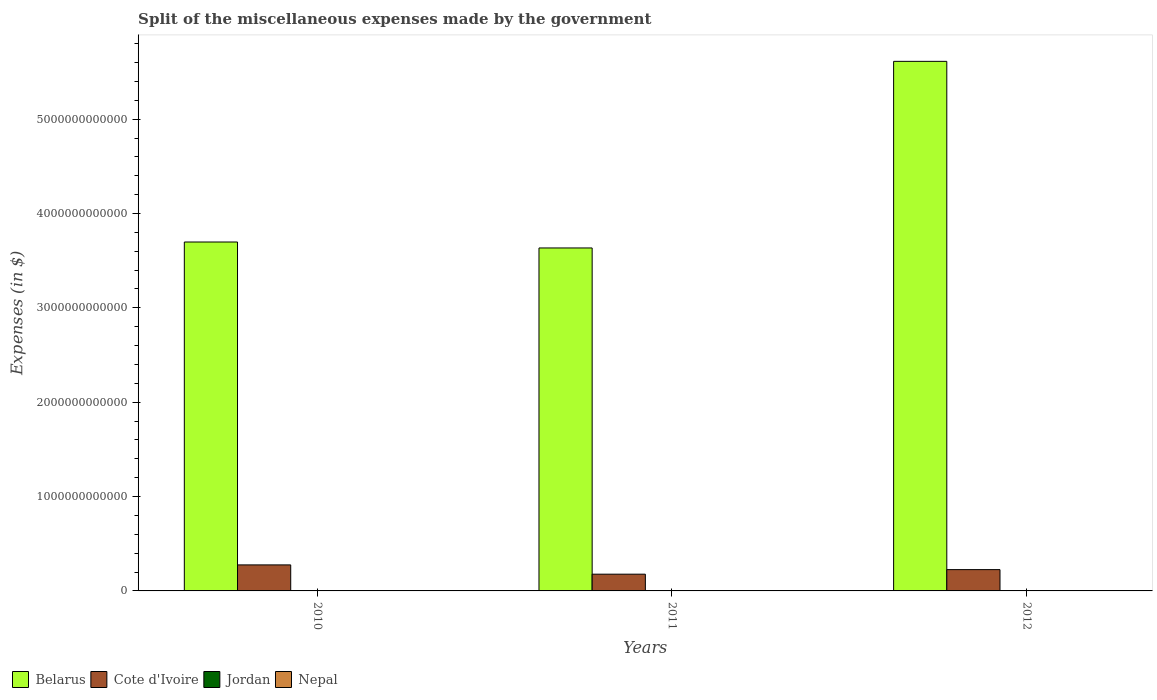How many different coloured bars are there?
Keep it short and to the point. 4. Are the number of bars per tick equal to the number of legend labels?
Offer a very short reply. Yes. What is the label of the 3rd group of bars from the left?
Offer a terse response. 2012. What is the miscellaneous expenses made by the government in Jordan in 2012?
Offer a very short reply. 7.96e+07. Across all years, what is the maximum miscellaneous expenses made by the government in Cote d'Ivoire?
Ensure brevity in your answer.  2.76e+11. Across all years, what is the minimum miscellaneous expenses made by the government in Belarus?
Give a very brief answer. 3.63e+12. In which year was the miscellaneous expenses made by the government in Cote d'Ivoire maximum?
Offer a very short reply. 2010. What is the total miscellaneous expenses made by the government in Cote d'Ivoire in the graph?
Give a very brief answer. 6.79e+11. What is the difference between the miscellaneous expenses made by the government in Cote d'Ivoire in 2010 and that in 2011?
Offer a terse response. 9.83e+1. What is the difference between the miscellaneous expenses made by the government in Nepal in 2011 and the miscellaneous expenses made by the government in Belarus in 2012?
Ensure brevity in your answer.  -5.61e+12. What is the average miscellaneous expenses made by the government in Cote d'Ivoire per year?
Provide a succinct answer. 2.26e+11. In the year 2010, what is the difference between the miscellaneous expenses made by the government in Nepal and miscellaneous expenses made by the government in Belarus?
Offer a very short reply. -3.70e+12. What is the ratio of the miscellaneous expenses made by the government in Belarus in 2010 to that in 2011?
Give a very brief answer. 1.02. Is the miscellaneous expenses made by the government in Jordan in 2010 less than that in 2012?
Your answer should be compact. No. What is the difference between the highest and the second highest miscellaneous expenses made by the government in Cote d'Ivoire?
Offer a terse response. 5.00e+1. What is the difference between the highest and the lowest miscellaneous expenses made by the government in Jordan?
Your response must be concise. 1.71e+07. Is the sum of the miscellaneous expenses made by the government in Belarus in 2011 and 2012 greater than the maximum miscellaneous expenses made by the government in Nepal across all years?
Offer a terse response. Yes. Is it the case that in every year, the sum of the miscellaneous expenses made by the government in Cote d'Ivoire and miscellaneous expenses made by the government in Jordan is greater than the sum of miscellaneous expenses made by the government in Belarus and miscellaneous expenses made by the government in Nepal?
Ensure brevity in your answer.  No. What does the 4th bar from the left in 2010 represents?
Keep it short and to the point. Nepal. What does the 2nd bar from the right in 2010 represents?
Your response must be concise. Jordan. Is it the case that in every year, the sum of the miscellaneous expenses made by the government in Jordan and miscellaneous expenses made by the government in Nepal is greater than the miscellaneous expenses made by the government in Cote d'Ivoire?
Provide a short and direct response. No. How many bars are there?
Give a very brief answer. 12. What is the difference between two consecutive major ticks on the Y-axis?
Your answer should be compact. 1.00e+12. Does the graph contain any zero values?
Keep it short and to the point. No. Where does the legend appear in the graph?
Your answer should be very brief. Bottom left. How many legend labels are there?
Your answer should be very brief. 4. How are the legend labels stacked?
Ensure brevity in your answer.  Horizontal. What is the title of the graph?
Your answer should be compact. Split of the miscellaneous expenses made by the government. Does "Faeroe Islands" appear as one of the legend labels in the graph?
Make the answer very short. No. What is the label or title of the Y-axis?
Provide a succinct answer. Expenses (in $). What is the Expenses (in $) of Belarus in 2010?
Ensure brevity in your answer.  3.70e+12. What is the Expenses (in $) of Cote d'Ivoire in 2010?
Your response must be concise. 2.76e+11. What is the Expenses (in $) of Jordan in 2010?
Offer a very short reply. 9.67e+07. What is the Expenses (in $) of Nepal in 2010?
Your response must be concise. 1.38e+09. What is the Expenses (in $) in Belarus in 2011?
Offer a very short reply. 3.63e+12. What is the Expenses (in $) of Cote d'Ivoire in 2011?
Offer a terse response. 1.77e+11. What is the Expenses (in $) in Jordan in 2011?
Ensure brevity in your answer.  8.67e+07. What is the Expenses (in $) of Nepal in 2011?
Your answer should be very brief. 1.86e+09. What is the Expenses (in $) of Belarus in 2012?
Make the answer very short. 5.61e+12. What is the Expenses (in $) in Cote d'Ivoire in 2012?
Your answer should be compact. 2.26e+11. What is the Expenses (in $) of Jordan in 2012?
Ensure brevity in your answer.  7.96e+07. What is the Expenses (in $) of Nepal in 2012?
Keep it short and to the point. 2.00e+09. Across all years, what is the maximum Expenses (in $) in Belarus?
Offer a very short reply. 5.61e+12. Across all years, what is the maximum Expenses (in $) in Cote d'Ivoire?
Your answer should be very brief. 2.76e+11. Across all years, what is the maximum Expenses (in $) of Jordan?
Your answer should be very brief. 9.67e+07. Across all years, what is the maximum Expenses (in $) of Nepal?
Give a very brief answer. 2.00e+09. Across all years, what is the minimum Expenses (in $) in Belarus?
Your answer should be compact. 3.63e+12. Across all years, what is the minimum Expenses (in $) in Cote d'Ivoire?
Make the answer very short. 1.77e+11. Across all years, what is the minimum Expenses (in $) in Jordan?
Give a very brief answer. 7.96e+07. Across all years, what is the minimum Expenses (in $) of Nepal?
Your response must be concise. 1.38e+09. What is the total Expenses (in $) in Belarus in the graph?
Provide a succinct answer. 1.29e+13. What is the total Expenses (in $) of Cote d'Ivoire in the graph?
Make the answer very short. 6.79e+11. What is the total Expenses (in $) in Jordan in the graph?
Your answer should be very brief. 2.63e+08. What is the total Expenses (in $) of Nepal in the graph?
Offer a very short reply. 5.24e+09. What is the difference between the Expenses (in $) in Belarus in 2010 and that in 2011?
Your answer should be very brief. 6.31e+1. What is the difference between the Expenses (in $) of Cote d'Ivoire in 2010 and that in 2011?
Keep it short and to the point. 9.83e+1. What is the difference between the Expenses (in $) in Jordan in 2010 and that in 2011?
Keep it short and to the point. 1.00e+07. What is the difference between the Expenses (in $) of Nepal in 2010 and that in 2011?
Offer a very short reply. -4.77e+08. What is the difference between the Expenses (in $) in Belarus in 2010 and that in 2012?
Your answer should be very brief. -1.91e+12. What is the difference between the Expenses (in $) in Cote d'Ivoire in 2010 and that in 2012?
Provide a short and direct response. 5.00e+1. What is the difference between the Expenses (in $) of Jordan in 2010 and that in 2012?
Your answer should be very brief. 1.71e+07. What is the difference between the Expenses (in $) of Nepal in 2010 and that in 2012?
Your answer should be very brief. -6.13e+08. What is the difference between the Expenses (in $) in Belarus in 2011 and that in 2012?
Provide a succinct answer. -1.98e+12. What is the difference between the Expenses (in $) in Cote d'Ivoire in 2011 and that in 2012?
Your response must be concise. -4.83e+1. What is the difference between the Expenses (in $) of Jordan in 2011 and that in 2012?
Ensure brevity in your answer.  7.10e+06. What is the difference between the Expenses (in $) in Nepal in 2011 and that in 2012?
Keep it short and to the point. -1.36e+08. What is the difference between the Expenses (in $) in Belarus in 2010 and the Expenses (in $) in Cote d'Ivoire in 2011?
Your response must be concise. 3.52e+12. What is the difference between the Expenses (in $) of Belarus in 2010 and the Expenses (in $) of Jordan in 2011?
Your answer should be very brief. 3.70e+12. What is the difference between the Expenses (in $) of Belarus in 2010 and the Expenses (in $) of Nepal in 2011?
Offer a terse response. 3.70e+12. What is the difference between the Expenses (in $) of Cote d'Ivoire in 2010 and the Expenses (in $) of Jordan in 2011?
Keep it short and to the point. 2.76e+11. What is the difference between the Expenses (in $) of Cote d'Ivoire in 2010 and the Expenses (in $) of Nepal in 2011?
Keep it short and to the point. 2.74e+11. What is the difference between the Expenses (in $) of Jordan in 2010 and the Expenses (in $) of Nepal in 2011?
Your answer should be compact. -1.76e+09. What is the difference between the Expenses (in $) in Belarus in 2010 and the Expenses (in $) in Cote d'Ivoire in 2012?
Offer a terse response. 3.47e+12. What is the difference between the Expenses (in $) in Belarus in 2010 and the Expenses (in $) in Jordan in 2012?
Offer a very short reply. 3.70e+12. What is the difference between the Expenses (in $) of Belarus in 2010 and the Expenses (in $) of Nepal in 2012?
Offer a very short reply. 3.70e+12. What is the difference between the Expenses (in $) of Cote d'Ivoire in 2010 and the Expenses (in $) of Jordan in 2012?
Ensure brevity in your answer.  2.76e+11. What is the difference between the Expenses (in $) in Cote d'Ivoire in 2010 and the Expenses (in $) in Nepal in 2012?
Provide a short and direct response. 2.74e+11. What is the difference between the Expenses (in $) of Jordan in 2010 and the Expenses (in $) of Nepal in 2012?
Make the answer very short. -1.90e+09. What is the difference between the Expenses (in $) of Belarus in 2011 and the Expenses (in $) of Cote d'Ivoire in 2012?
Your response must be concise. 3.41e+12. What is the difference between the Expenses (in $) in Belarus in 2011 and the Expenses (in $) in Jordan in 2012?
Offer a terse response. 3.63e+12. What is the difference between the Expenses (in $) in Belarus in 2011 and the Expenses (in $) in Nepal in 2012?
Offer a very short reply. 3.63e+12. What is the difference between the Expenses (in $) in Cote d'Ivoire in 2011 and the Expenses (in $) in Jordan in 2012?
Your answer should be very brief. 1.77e+11. What is the difference between the Expenses (in $) of Cote d'Ivoire in 2011 and the Expenses (in $) of Nepal in 2012?
Offer a very short reply. 1.75e+11. What is the difference between the Expenses (in $) in Jordan in 2011 and the Expenses (in $) in Nepal in 2012?
Your response must be concise. -1.91e+09. What is the average Expenses (in $) of Belarus per year?
Your response must be concise. 4.32e+12. What is the average Expenses (in $) in Cote d'Ivoire per year?
Offer a terse response. 2.26e+11. What is the average Expenses (in $) in Jordan per year?
Keep it short and to the point. 8.77e+07. What is the average Expenses (in $) in Nepal per year?
Your answer should be compact. 1.75e+09. In the year 2010, what is the difference between the Expenses (in $) of Belarus and Expenses (in $) of Cote d'Ivoire?
Your response must be concise. 3.42e+12. In the year 2010, what is the difference between the Expenses (in $) of Belarus and Expenses (in $) of Jordan?
Your response must be concise. 3.70e+12. In the year 2010, what is the difference between the Expenses (in $) in Belarus and Expenses (in $) in Nepal?
Ensure brevity in your answer.  3.70e+12. In the year 2010, what is the difference between the Expenses (in $) in Cote d'Ivoire and Expenses (in $) in Jordan?
Your answer should be compact. 2.76e+11. In the year 2010, what is the difference between the Expenses (in $) in Cote d'Ivoire and Expenses (in $) in Nepal?
Offer a terse response. 2.74e+11. In the year 2010, what is the difference between the Expenses (in $) of Jordan and Expenses (in $) of Nepal?
Keep it short and to the point. -1.29e+09. In the year 2011, what is the difference between the Expenses (in $) in Belarus and Expenses (in $) in Cote d'Ivoire?
Make the answer very short. 3.46e+12. In the year 2011, what is the difference between the Expenses (in $) in Belarus and Expenses (in $) in Jordan?
Provide a short and direct response. 3.63e+12. In the year 2011, what is the difference between the Expenses (in $) in Belarus and Expenses (in $) in Nepal?
Provide a short and direct response. 3.63e+12. In the year 2011, what is the difference between the Expenses (in $) in Cote d'Ivoire and Expenses (in $) in Jordan?
Your response must be concise. 1.77e+11. In the year 2011, what is the difference between the Expenses (in $) of Cote d'Ivoire and Expenses (in $) of Nepal?
Provide a short and direct response. 1.76e+11. In the year 2011, what is the difference between the Expenses (in $) of Jordan and Expenses (in $) of Nepal?
Keep it short and to the point. -1.77e+09. In the year 2012, what is the difference between the Expenses (in $) of Belarus and Expenses (in $) of Cote d'Ivoire?
Provide a short and direct response. 5.39e+12. In the year 2012, what is the difference between the Expenses (in $) in Belarus and Expenses (in $) in Jordan?
Provide a short and direct response. 5.61e+12. In the year 2012, what is the difference between the Expenses (in $) of Belarus and Expenses (in $) of Nepal?
Ensure brevity in your answer.  5.61e+12. In the year 2012, what is the difference between the Expenses (in $) in Cote d'Ivoire and Expenses (in $) in Jordan?
Your answer should be compact. 2.26e+11. In the year 2012, what is the difference between the Expenses (in $) in Cote d'Ivoire and Expenses (in $) in Nepal?
Provide a short and direct response. 2.24e+11. In the year 2012, what is the difference between the Expenses (in $) in Jordan and Expenses (in $) in Nepal?
Provide a succinct answer. -1.92e+09. What is the ratio of the Expenses (in $) of Belarus in 2010 to that in 2011?
Keep it short and to the point. 1.02. What is the ratio of the Expenses (in $) in Cote d'Ivoire in 2010 to that in 2011?
Offer a very short reply. 1.55. What is the ratio of the Expenses (in $) in Jordan in 2010 to that in 2011?
Your answer should be compact. 1.12. What is the ratio of the Expenses (in $) of Nepal in 2010 to that in 2011?
Ensure brevity in your answer.  0.74. What is the ratio of the Expenses (in $) of Belarus in 2010 to that in 2012?
Keep it short and to the point. 0.66. What is the ratio of the Expenses (in $) in Cote d'Ivoire in 2010 to that in 2012?
Offer a very short reply. 1.22. What is the ratio of the Expenses (in $) in Jordan in 2010 to that in 2012?
Provide a succinct answer. 1.21. What is the ratio of the Expenses (in $) of Nepal in 2010 to that in 2012?
Keep it short and to the point. 0.69. What is the ratio of the Expenses (in $) of Belarus in 2011 to that in 2012?
Your response must be concise. 0.65. What is the ratio of the Expenses (in $) of Cote d'Ivoire in 2011 to that in 2012?
Ensure brevity in your answer.  0.79. What is the ratio of the Expenses (in $) of Jordan in 2011 to that in 2012?
Your answer should be compact. 1.09. What is the ratio of the Expenses (in $) of Nepal in 2011 to that in 2012?
Give a very brief answer. 0.93. What is the difference between the highest and the second highest Expenses (in $) in Belarus?
Ensure brevity in your answer.  1.91e+12. What is the difference between the highest and the second highest Expenses (in $) in Cote d'Ivoire?
Your answer should be very brief. 5.00e+1. What is the difference between the highest and the second highest Expenses (in $) of Nepal?
Give a very brief answer. 1.36e+08. What is the difference between the highest and the lowest Expenses (in $) in Belarus?
Your answer should be very brief. 1.98e+12. What is the difference between the highest and the lowest Expenses (in $) of Cote d'Ivoire?
Offer a terse response. 9.83e+1. What is the difference between the highest and the lowest Expenses (in $) in Jordan?
Your answer should be compact. 1.71e+07. What is the difference between the highest and the lowest Expenses (in $) in Nepal?
Offer a very short reply. 6.13e+08. 